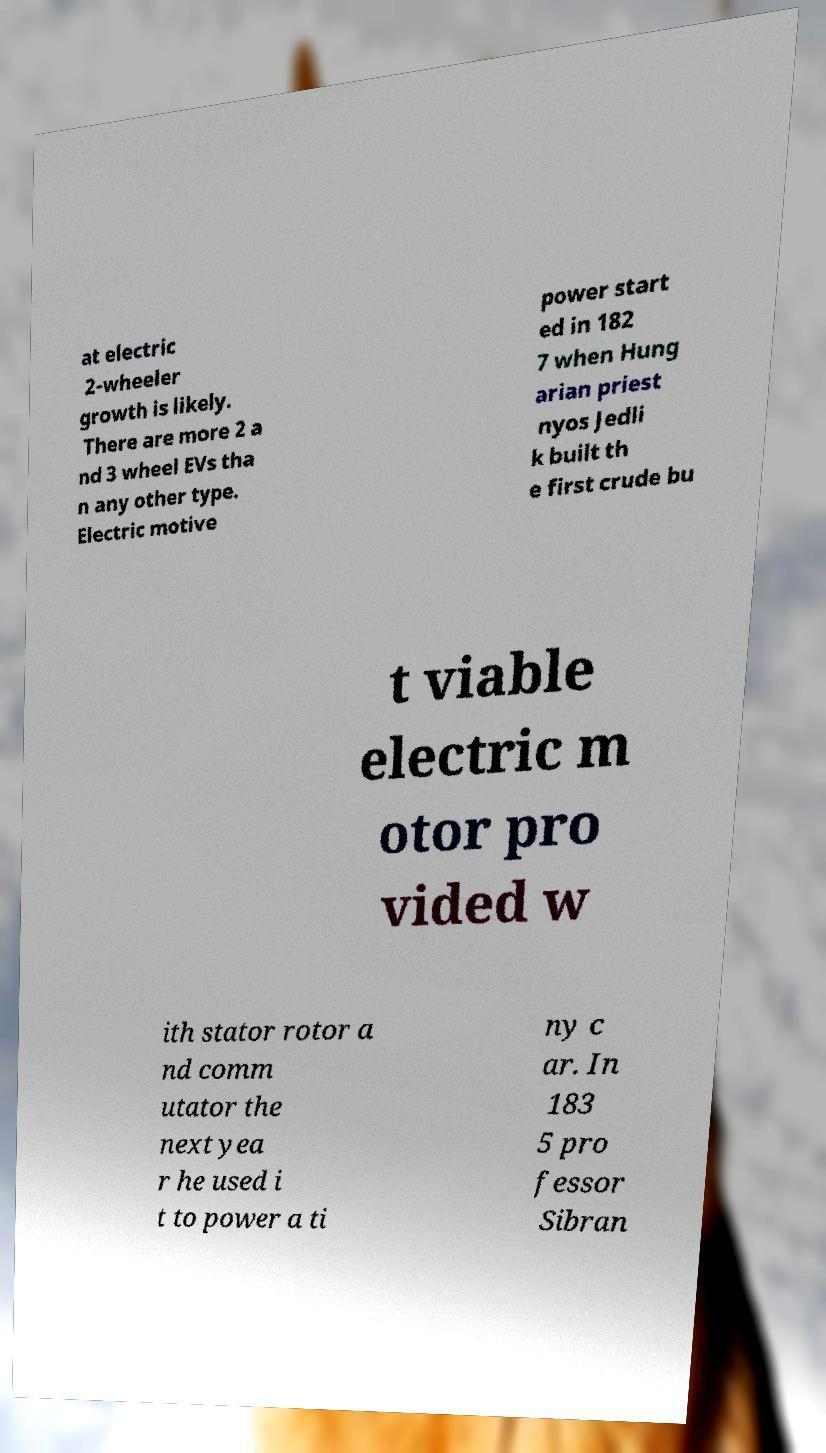I need the written content from this picture converted into text. Can you do that? at electric 2-wheeler growth is likely. There are more 2 a nd 3 wheel EVs tha n any other type. Electric motive power start ed in 182 7 when Hung arian priest nyos Jedli k built th e first crude bu t viable electric m otor pro vided w ith stator rotor a nd comm utator the next yea r he used i t to power a ti ny c ar. In 183 5 pro fessor Sibran 